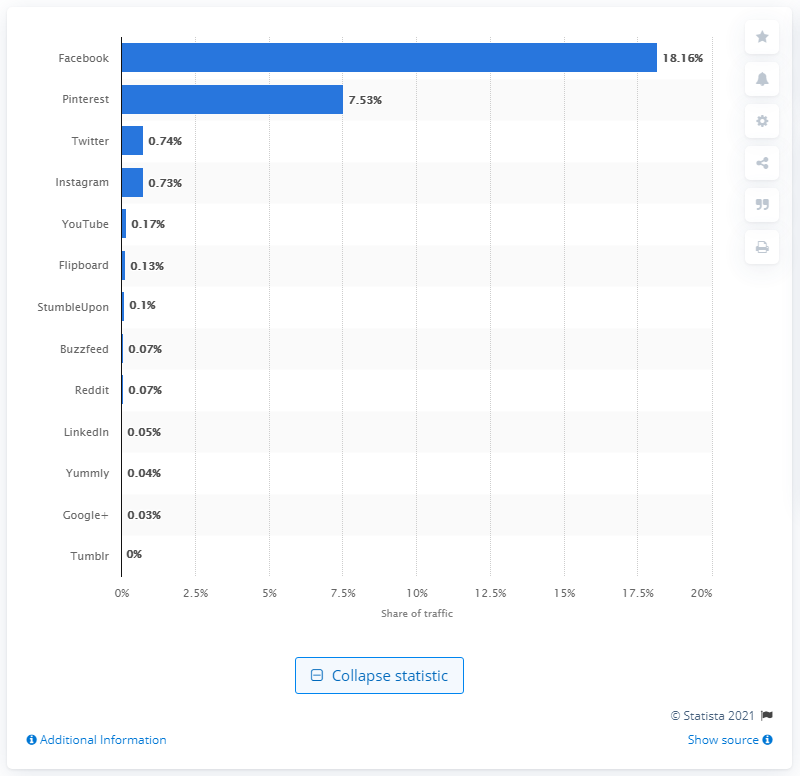Mention a couple of crucial points in this snapshot. According to data, Pinterest accounted for 7.53% of global referral traffic in the second half of 2017. 